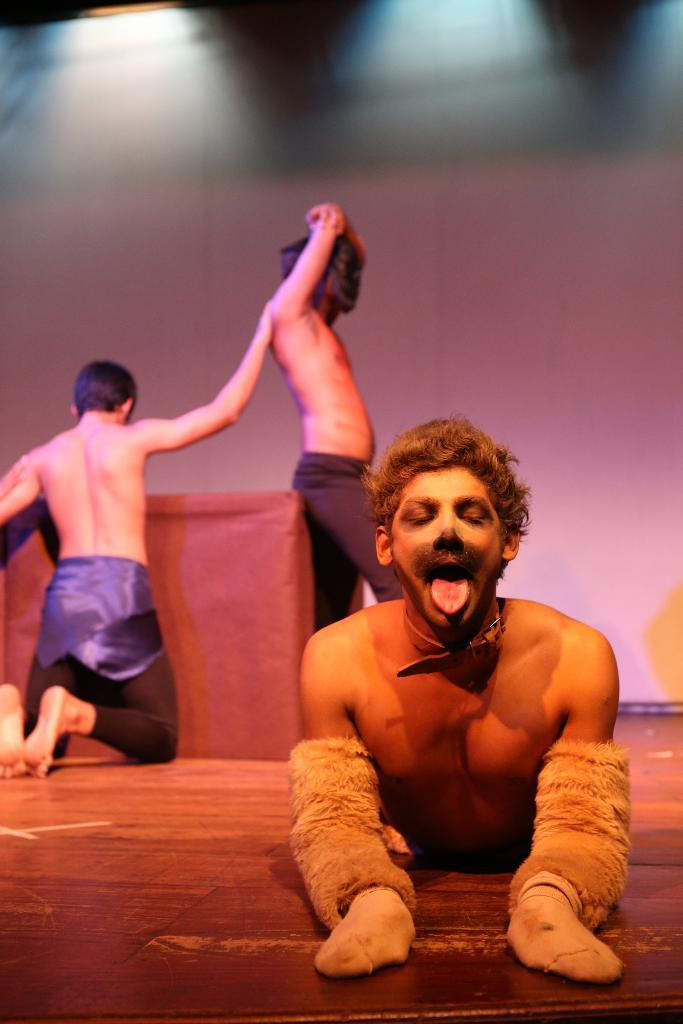How many people are in the image? There are three persons in the image. What can be seen in the background of the image? There is a wall in the background of the image. What object is present in the image that people might sit or stand around? There is a table in the image. What color is the mind of the person on the left in the image? There is no mention of a mind or its color in the image, as minds are not visible. 